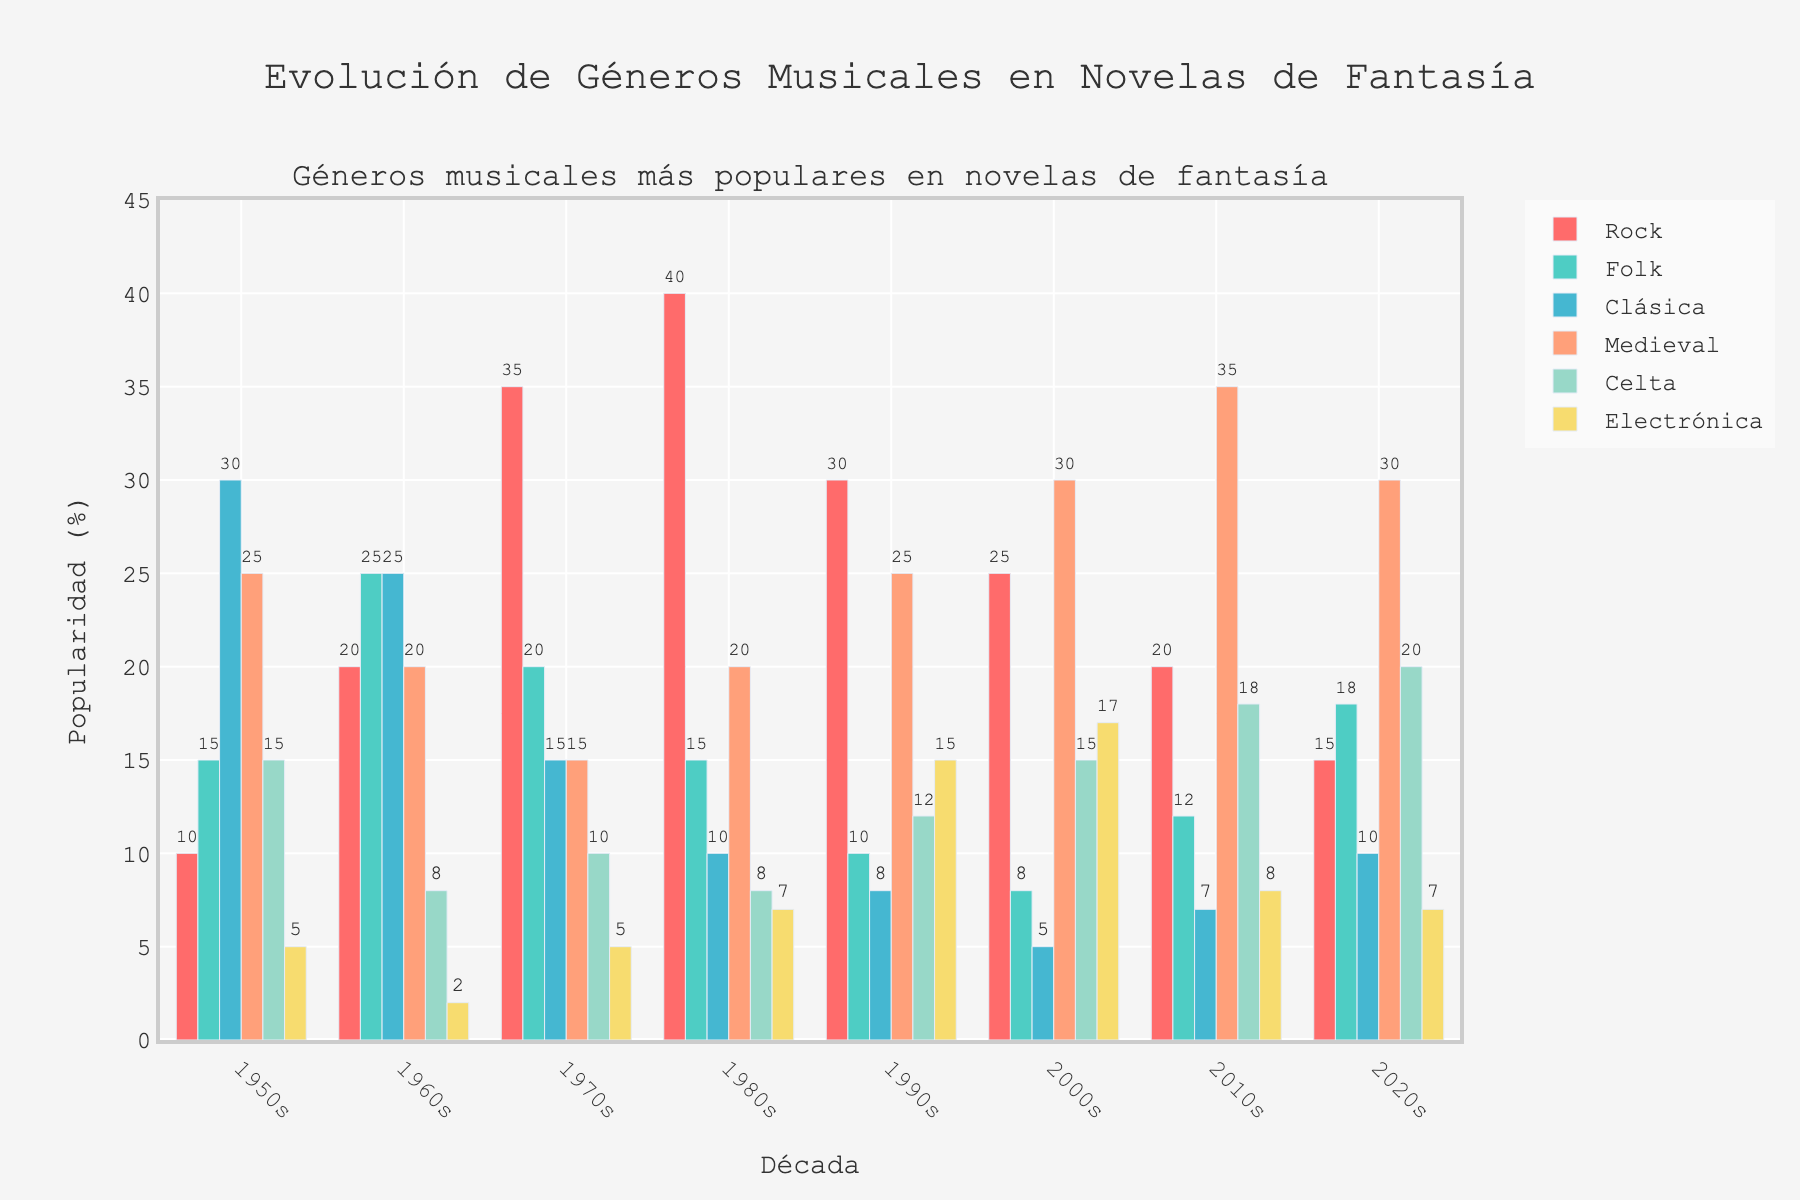Which genre had the highest popularity in the 1980s? By examining the bar heights in the 1980s, the tallest bar corresponds to Rock. This means Rock had the highest popularity in the 1980s.
Answer: Rock How did the popularity of Classical music change from the 1950s to the 2010s? In the 1950s, Classical music had a popularity of 30%, and in the 2010s, it had 7%. The difference is 30% - 7% = 23%. Therefore, the popularity decreased by 23 percentage points.
Answer: Decreased by 23 percentage points Which decade saw the highest popularity of Folk music? By comparing the bar heights for Folk music across all decades, the 1960s had the tallest bar with 25%. Thus, the 1960s saw the highest popularity of Folk music.
Answer: 1960s What is the total popularity of Celtic music across all decades? Summing up the values for Celtic music in all decades: 15% (1950s) + 8% (1960s) + 10% (1970s) + 8% (1980s) + 12% (1990s) + 15% (2000s) + 18% (2010s) + 20% (2020s) = 106%.
Answer: 106% Compare the popularity of Medieval music in the 1950s to the 2020s. Which decade had higher popularity? The bar for Medieval music in the 1950s is 25% and in the 2020s is 30%. Comparing these, the 2020s had higher popularity of Medieval music.
Answer: 2020s What is the difference in popularity of Electronic music between the 1990s and 2000s? In the 1990s, Electronic music had a popularity of 15%, and in the 2000s, it had 17%. The difference is 17% - 15% = 2%.
Answer: 2% Which genre's popularity remained within 5-10% range throughout all decades? By examining the bars for each genre, Classical music consistently falls within the range of 5-10% from the 1970s onwards.
Answer: Classical What is the most popular genre in the 2000s and how does it compare to its popularity in the 1950s? The tallest bar in the 2000s corresponds to Medieval music at 30%. In the 1950s, Medieval music had a popularity of 25%. Comparing these, Medieval music increased by 5 percentage points from 25% to 30%.
Answer: Medieval, increased by 5 percentage points Which decade saw the highest overall total popularity across all genres? Summing up the values for each decade: 
1950s: 100%, 1960s: 100%, 1970s: 100%, 1980s: 100%, 1990s: 100%, 2000s: 100%, 2010s: 100%, 2020s: 100%. All decades have equal overall popularity of 100%.
Answer: All decades equal at 100% What is the median popularity of Rock music across all decades? The popularity of Rock across decades is: 10, 20, 35, 40, 30, 25, 20, 15. Arranging these values in ascending order: 10, 15, 20, 20, 25, 30, 35, 40. The median value (middle value) is the average of 20 and 25, i.e., (20 + 25)/2 = 22.5%.
Answer: 22.5% 